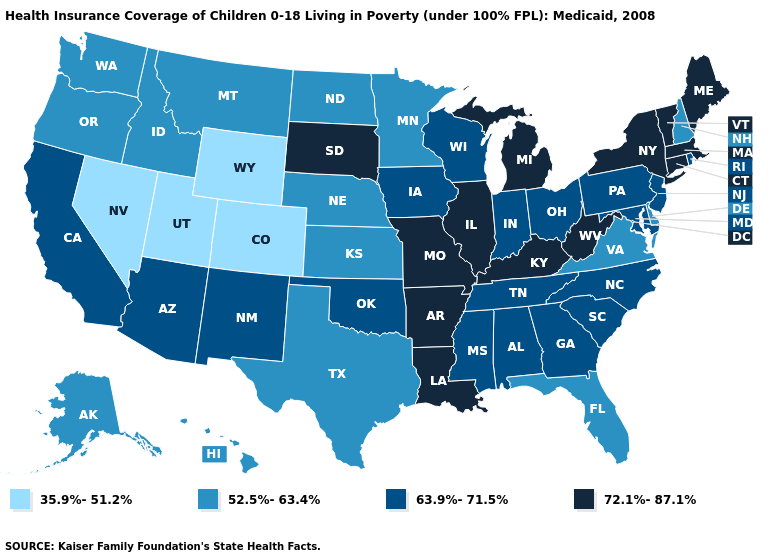What is the value of Iowa?
Concise answer only. 63.9%-71.5%. What is the value of California?
Be succinct. 63.9%-71.5%. How many symbols are there in the legend?
Short answer required. 4. Name the states that have a value in the range 63.9%-71.5%?
Give a very brief answer. Alabama, Arizona, California, Georgia, Indiana, Iowa, Maryland, Mississippi, New Jersey, New Mexico, North Carolina, Ohio, Oklahoma, Pennsylvania, Rhode Island, South Carolina, Tennessee, Wisconsin. Name the states that have a value in the range 63.9%-71.5%?
Quick response, please. Alabama, Arizona, California, Georgia, Indiana, Iowa, Maryland, Mississippi, New Jersey, New Mexico, North Carolina, Ohio, Oklahoma, Pennsylvania, Rhode Island, South Carolina, Tennessee, Wisconsin. Does California have the highest value in the USA?
Answer briefly. No. Which states have the highest value in the USA?
Concise answer only. Arkansas, Connecticut, Illinois, Kentucky, Louisiana, Maine, Massachusetts, Michigan, Missouri, New York, South Dakota, Vermont, West Virginia. Name the states that have a value in the range 52.5%-63.4%?
Quick response, please. Alaska, Delaware, Florida, Hawaii, Idaho, Kansas, Minnesota, Montana, Nebraska, New Hampshire, North Dakota, Oregon, Texas, Virginia, Washington. What is the highest value in states that border Missouri?
Give a very brief answer. 72.1%-87.1%. Which states have the lowest value in the USA?
Give a very brief answer. Colorado, Nevada, Utah, Wyoming. What is the highest value in the South ?
Give a very brief answer. 72.1%-87.1%. What is the value of Delaware?
Answer briefly. 52.5%-63.4%. What is the lowest value in the South?
Short answer required. 52.5%-63.4%. Among the states that border Kansas , which have the highest value?
Keep it brief. Missouri. Which states have the lowest value in the South?
Concise answer only. Delaware, Florida, Texas, Virginia. 